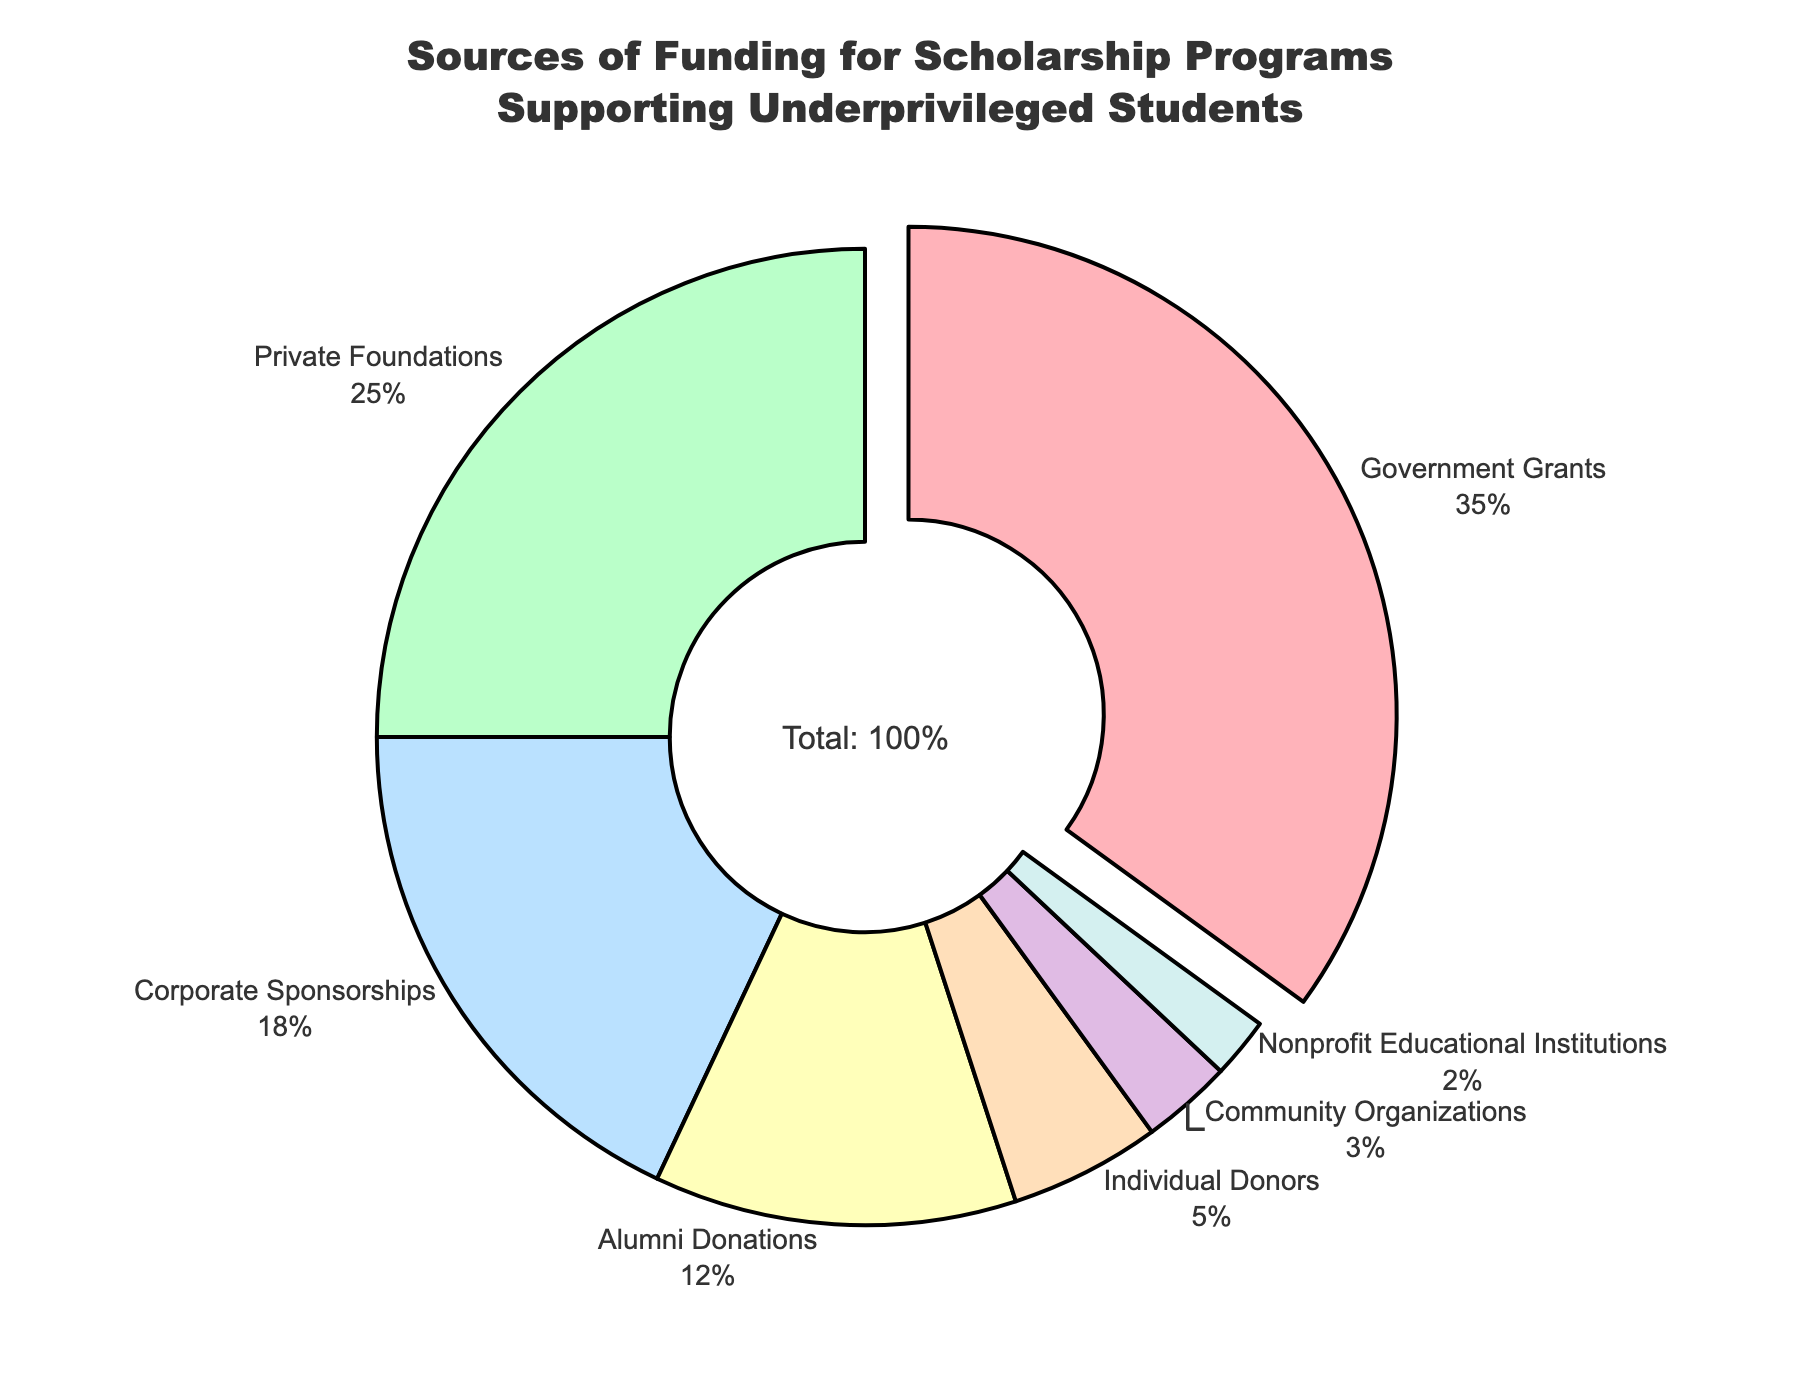Which source contributes the largest percentage to the funding? The segment with the largest percentage is visually distinguished by being pulled out slightly from the pie chart for emphasis. This corresponds to "Government Grants" and is labeled with 35%.
Answer: Government Grants Which two sources combined contribute more than 50% of the funding? Combined percentages of "Government Grants" (35%) and "Private Foundations" (25%) sum up to (35 + 25) = 60%, which is more than 50%.
Answer: Government Grants and Private Foundations How much more do Corporate Sponsorships contribute compared to Community Organizations? Corporate Sponsorships contribute 18% and Community Organizations contribute 3%. The difference is (18 - 3) = 15%.
Answer: 15% Which funding source contributes the least percentage? The smallest segment in the pie chart, representing the smallest percentage, is attributed to "Nonprofit Educational Institutions" with 2%.
Answer: Nonprofit Educational Institutions What is the combined contribution percentage of Alumni Donations and Individual Donors? Alumni Donations have 12% and Individual Donors have 5%. Summing them up gives (12 + 5) = 17%.
Answer: 17% How does the contribution of Private Foundations compare to Corporate Sponsorships? Private Foundations contribute 25%, while Corporate Sponsorships contribute 18%. Comparing these, Private Foundations contribute more.
Answer: Private Foundations contribute more What's the difference in percentage between Alumni Donations and Individual Donors? Alumni Donations contribute 12% and Individual Donors contribute 5%. The difference is (12 - 5) = 7%.
Answer: 7% Which three sources combined contribute to almost half of the total funding? The sum of “Corporate Sponsorships” (18%), “Alumni Donations” (12%), and “Individual Donors” (5%) is (18 + 12 + 5) = 35%, which is not enough. Adding "Community Organizations" (3%) would only total 38%. Next largest options are “Private Foundations” (25%), “Corporate Sponsorships” (18%), "Alumni Donations" (12%) which sums up to 55%. This exceeds 50%. Hence,” Government Grants" (35%), and “Private Foundations” (25%) closely total 60%. The sum is quite closer to half rather lesser when computed for “Corporate Sponsorships” (18 %), “Alumni Donations” (12%), "Individual Donors" (5%) far outweighing much closer fewer visual pointers—indeed exceeding half of total mix remarkably in the fund structure within deeper analytics. __10%__ when computed behind is remanent unaccompanied.
Answer: Government Grants, Private Foundations and Corporate Sponsorships 